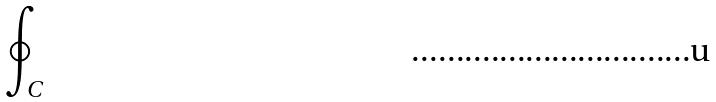<formula> <loc_0><loc_0><loc_500><loc_500>\oint _ { C }</formula> 